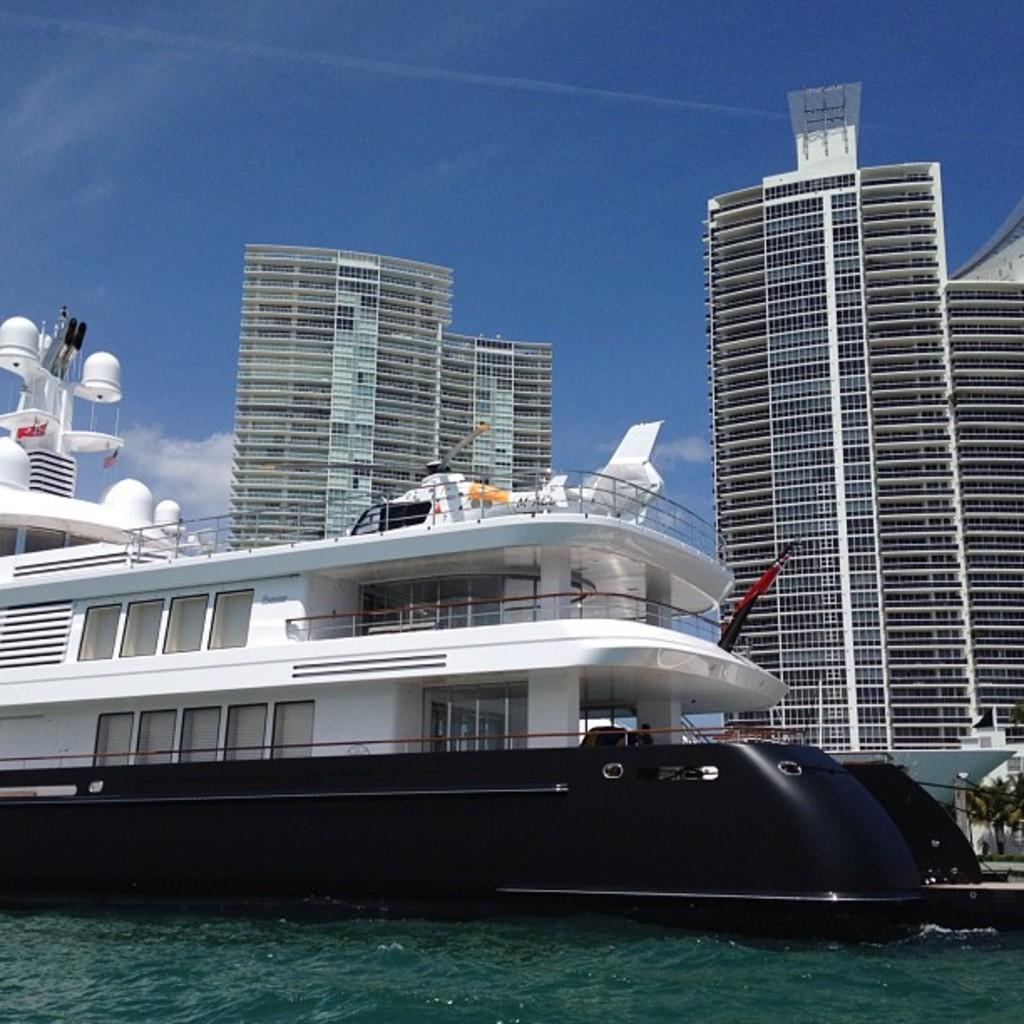What is visible at the top of the image? The sky is visible at the top of the image. What can be seen in the sky? There are clouds in the sky. What type of structures are present in the image? There are buildings in the image. What is the main subject of the image? The main subject of the image is a ship. What is visible at the bottom of the image? Water is visible at the bottom of the image. Where is the woman carrying a tray in the image? There is no woman carrying a tray in the image. What type of building is depicted in the image? The provided facts do not mention any specific type of building; only that there are buildings present. 